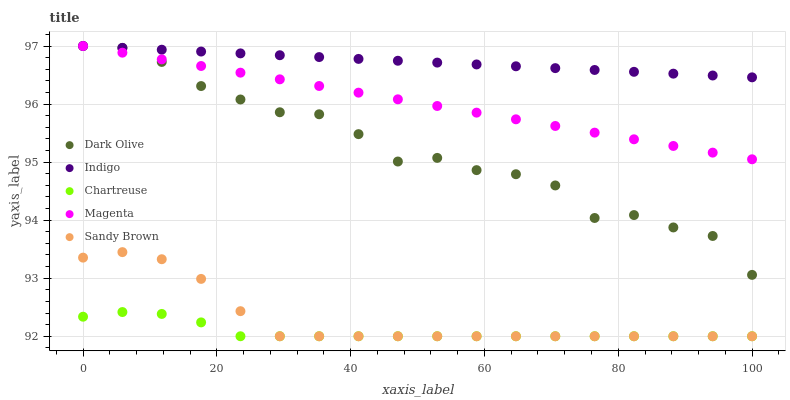Does Chartreuse have the minimum area under the curve?
Answer yes or no. Yes. Does Indigo have the maximum area under the curve?
Answer yes or no. Yes. Does Dark Olive have the minimum area under the curve?
Answer yes or no. No. Does Dark Olive have the maximum area under the curve?
Answer yes or no. No. Is Indigo the smoothest?
Answer yes or no. Yes. Is Dark Olive the roughest?
Answer yes or no. Yes. Is Chartreuse the smoothest?
Answer yes or no. No. Is Chartreuse the roughest?
Answer yes or no. No. Does Sandy Brown have the lowest value?
Answer yes or no. Yes. Does Dark Olive have the lowest value?
Answer yes or no. No. Does Magenta have the highest value?
Answer yes or no. Yes. Does Chartreuse have the highest value?
Answer yes or no. No. Is Sandy Brown less than Magenta?
Answer yes or no. Yes. Is Magenta greater than Sandy Brown?
Answer yes or no. Yes. Does Dark Olive intersect Magenta?
Answer yes or no. Yes. Is Dark Olive less than Magenta?
Answer yes or no. No. Is Dark Olive greater than Magenta?
Answer yes or no. No. Does Sandy Brown intersect Magenta?
Answer yes or no. No. 